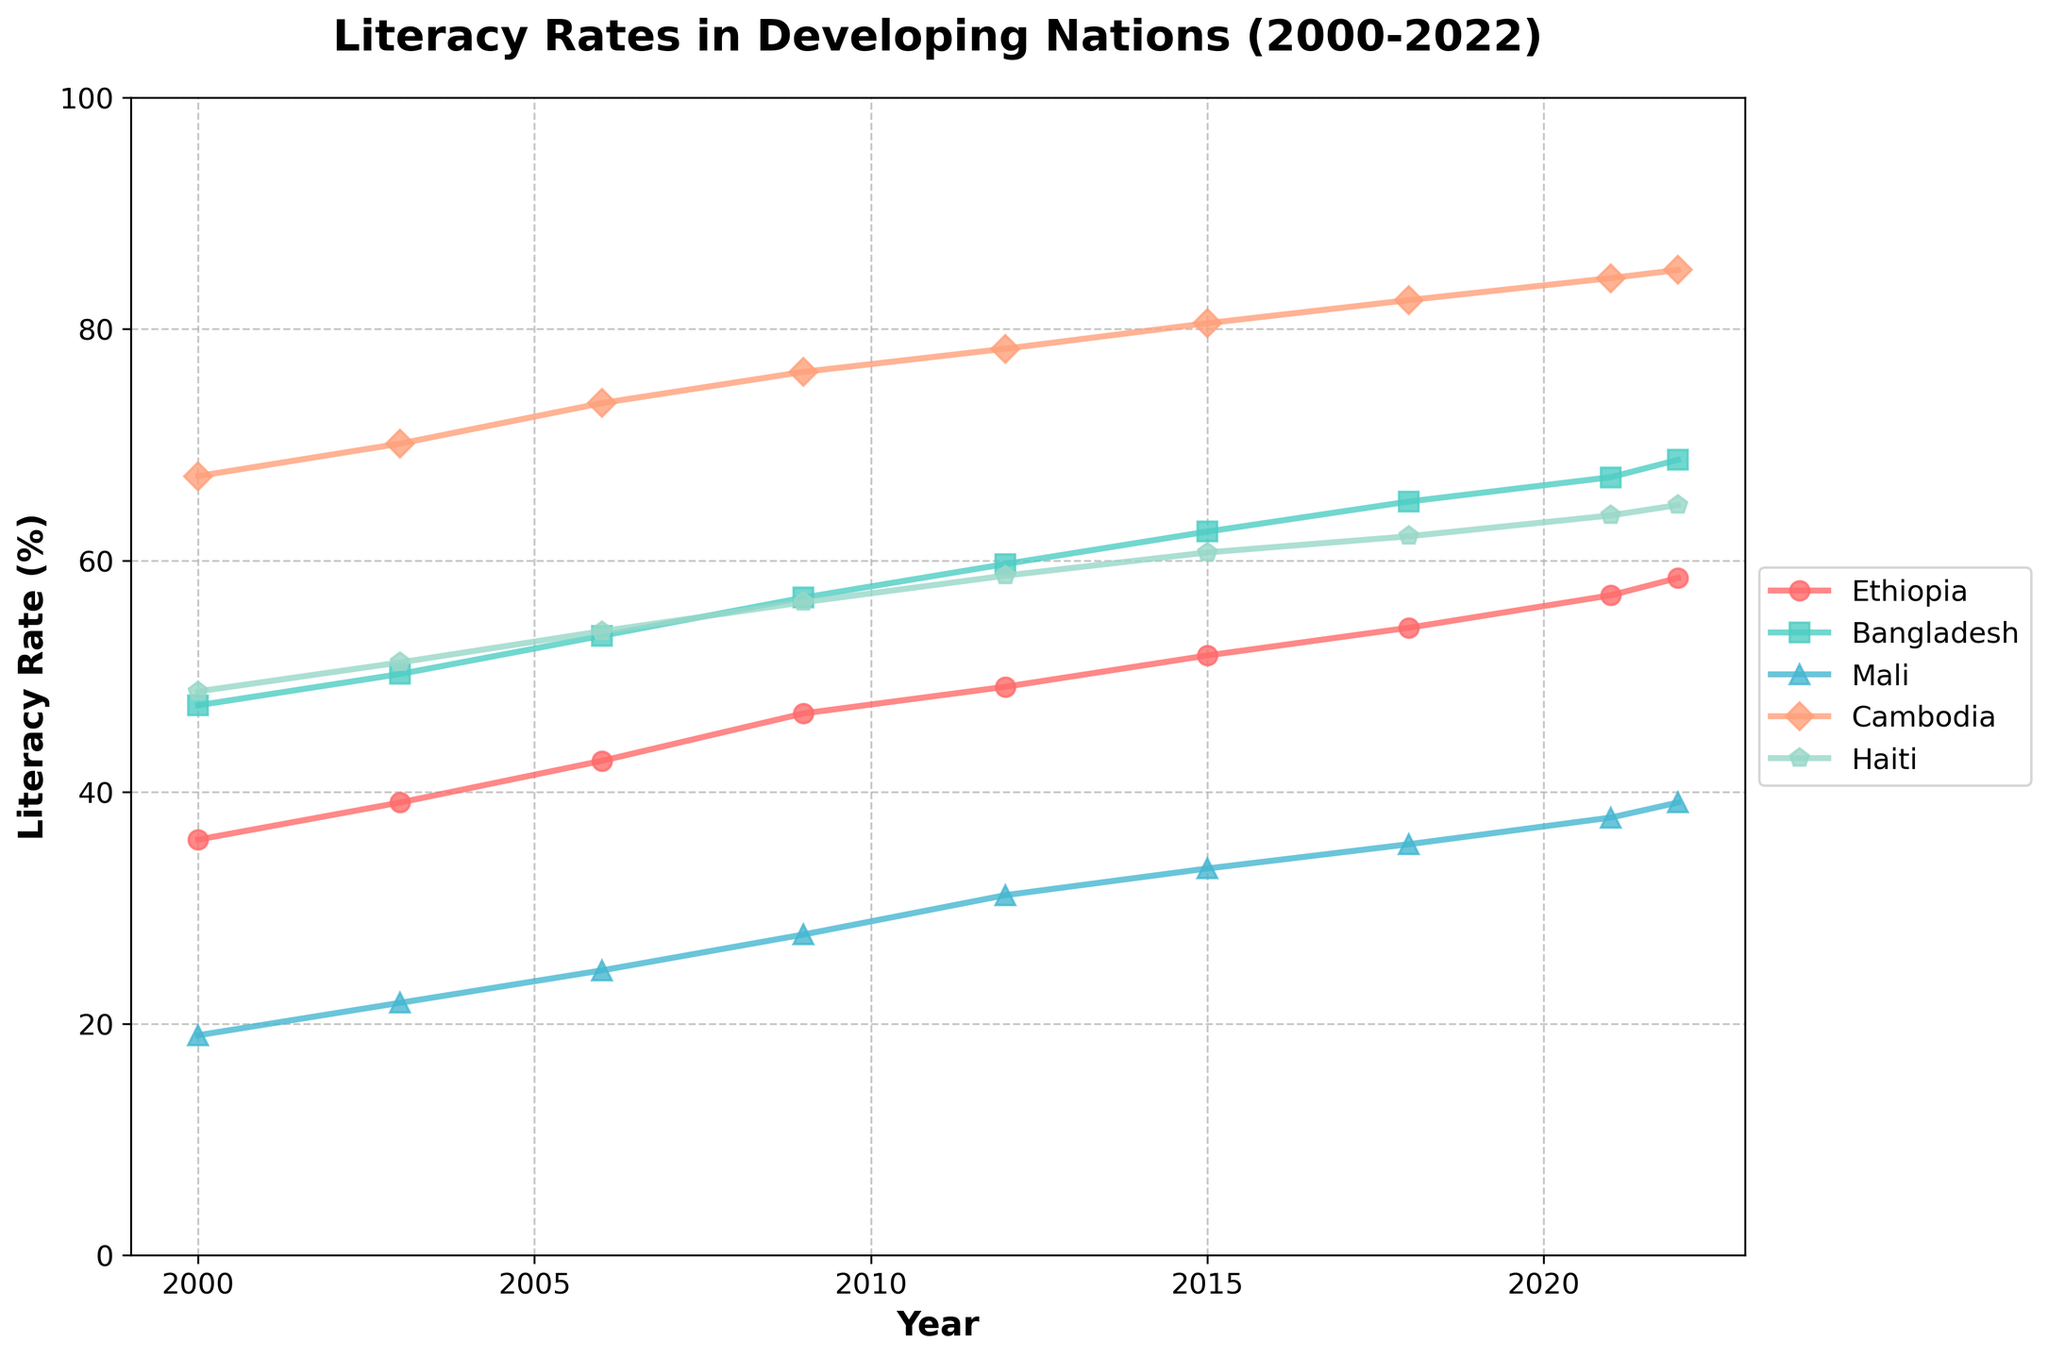What country had the highest literacy rate in 2022? Look at the literacy rates for each country in the year 2022. Cambodia has the highest literacy rate at 85.1%.
Answer: Cambodia What is the difference in literacy rates between Bangladesh and Haiti in 2022? Find the literacy rates for Bangladesh and Haiti in 2022 (68.7% and 64.8% respectively). Subtract Haiti's rate from Bangladesh's: 68.7% - 64.8% = 3.9%.
Answer: 3.9% Which country showed the most improvement in literacy rate from 2000 to 2022? Calculate the improvement for each country from 2000 to 2022. Ethiopia: 58.5% - 35.9% = 22.6%, Bangladesh: 68.7% - 47.5% = 21.2%, Mali: 39.1% - 19% = 20.1%, Cambodia: 85.1% - 67.3% = 17.8%, Haiti: 64.8% - 48.7% = 16.1%. Ethiopia has the highest improvement of 22.6%.
Answer: Ethiopia In which year did Bangladesh first surpass a 60% literacy rate? Identify the year where Bangladesh's literacy rate goes above 60% for the first time. In 2015, the literacy rate is 62.5%, which surpasses 60%.
Answer: 2015 Compare the literacy rates of Ethiopia and Mali in 2009. Which country had a lower rate and by how much? Find the 2009 literacy rates for Ethiopia (46.8%) and Mali (27.7%). Calculate the difference: 46.8% - 27.7% = 19.1%. Mali has a lower rate by 19.1%.
Answer: Mali by 19.1% What are the average literacy rates of Cambodia and Haiti over the entire period (2000-2022)? Sum the literacy rates for each year from 2000 to 2022 and divide by the number of years for Cambodia and Haiti. Cambodia: (67.3% + 70.1% + 73.6% + 76.3% + 78.3% + 80.5% + 82.5% + 84.4% + 85.1%) / 9 = 77.9%. Haiti: (48.7% + 51.2% + 53.9% + 56.4% + 58.7% + 60.7% + 62.1% + 63.9% + 64.8%) / 9 = 57.8%.
Answer: Cambodia: 77.9%, Haiti: 57.8% Between 2000 and 2022, which country experienced the least overall change in literacy rate? Determine the change for each country by subtracting the 2000 literacy rate from the 2022 literacy rate. Ethiopia: 22.6%, Bangladesh: 21.2%, Mali: 20.1%, Cambodia: 17.8%, Haiti: 16.1%. Haiti experienced the least change with 16.1%.
Answer: Haiti Identify a year where all countries showed some increase in literacy rate from the previous recorded year. Look for a year where every country's literacy rate is higher than in the previous recorded year. From 2018 to 2021, all countries show an increase in literacy rates.
Answer: 2018 to 2021 Which country had the smallest increase in literacy rate between 2003 and 2006? Calculate the increase for each country: Ethiopia (42.7% - 39.1% = 3.6%), Bangladesh (53.5% - 50.2% = 3.3%), Mali (24.6% - 21.8% = 2.8%), Cambodia (73.6% - 70.1% = 3.5%), Haiti (53.9% - 51.2% = 2.7%). Haiti had the smallest increase of 2.7%.
Answer: Haiti Which two countries had the closest literacy rates in 2021 and what is the difference? Compare the 2021 literacy rates for each pair of countries to find the closest. Bangladesh (67.2%) and Mali (37.8%) differ by 29.4%, Ethiopia (57.0%) and Cambodia (84.4%) differ by 27.4%, Haiti (63.9%) differs by 5.6% from Ethiopia (57.0%). Ethiopia and Haiti are the closest with a difference of 5.6%.
Answer: Ethiopia and Haiti, 5.6% 